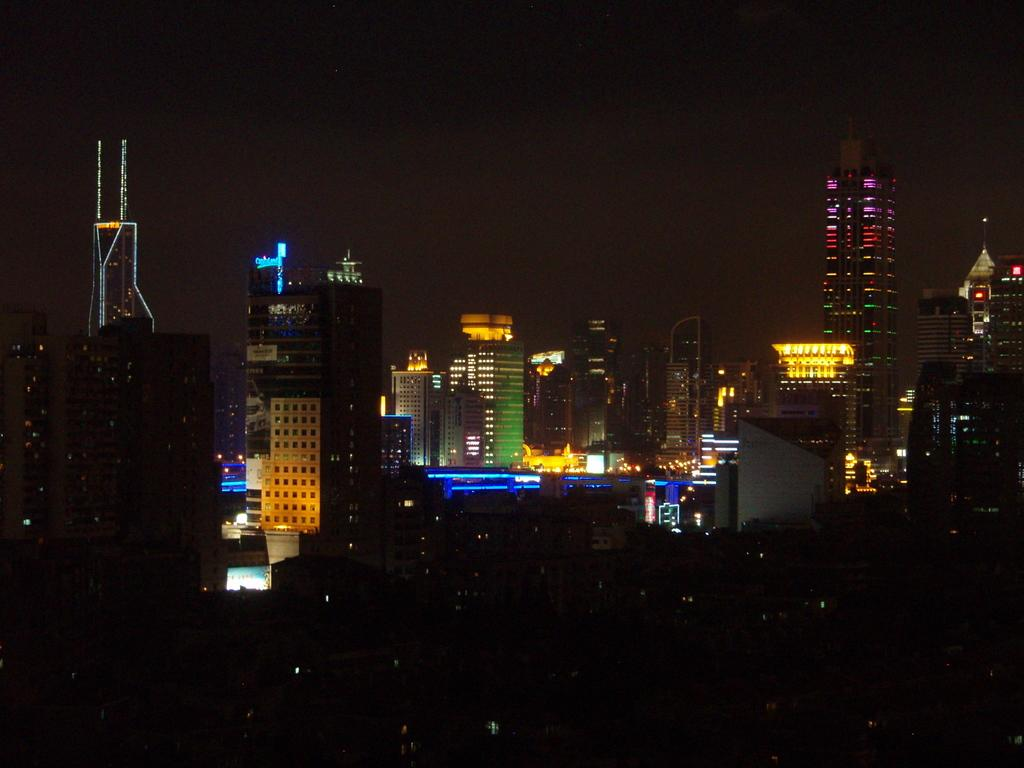What type of structures can be seen in the image? There are many buildings with lights in the image. What is the color of the background in the image? The background of the image is dark. What type of laborer can be seen working in the middle of the image? There is no laborer present in the image; it only features buildings with lights and a dark background. How is the image divided into sections? The image is not divided into sections; it is a continuous scene of buildings with lights and a dark background. 